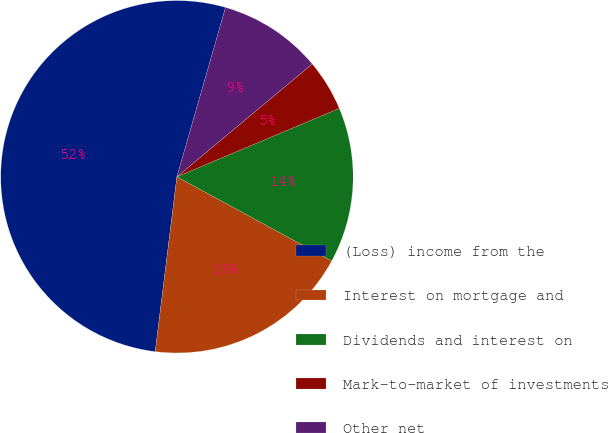Convert chart to OTSL. <chart><loc_0><loc_0><loc_500><loc_500><pie_chart><fcel>(Loss) income from the<fcel>Interest on mortgage and<fcel>Dividends and interest on<fcel>Mark-to-market of investments<fcel>Other net<nl><fcel>52.48%<fcel>19.04%<fcel>14.27%<fcel>4.71%<fcel>9.49%<nl></chart> 